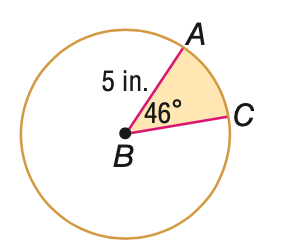Answer the mathemtical geometry problem and directly provide the correct option letter.
Question: Find the area of the shaded sector. Round to the nearest tenth, if necessary.
Choices: A: 10.0 B: 27.4 C: 65.5 D: 78.5 A 